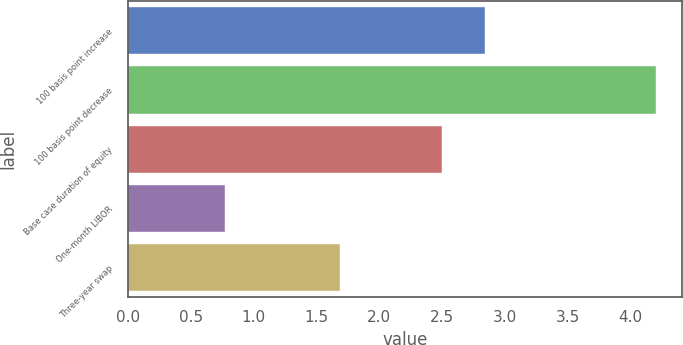Convert chart to OTSL. <chart><loc_0><loc_0><loc_500><loc_500><bar_chart><fcel>100 basis point increase<fcel>100 basis point decrease<fcel>Base case duration of equity<fcel>One-month LIBOR<fcel>Three-year swap<nl><fcel>2.84<fcel>4.2<fcel>2.5<fcel>0.77<fcel>1.69<nl></chart> 